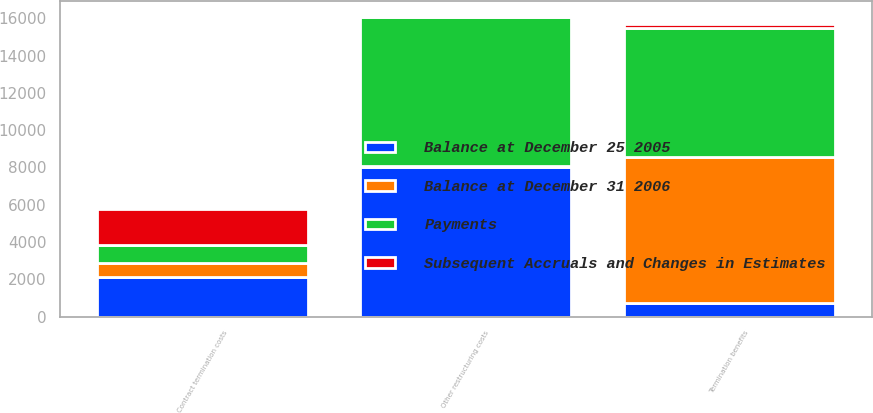<chart> <loc_0><loc_0><loc_500><loc_500><stacked_bar_chart><ecel><fcel>Termination benefits<fcel>Contract termination costs<fcel>Other restructuring costs<nl><fcel>Balance at December 31 2006<fcel>7848<fcel>775<fcel>31<nl><fcel>Balance at December 25 2005<fcel>706<fcel>2122<fcel>8039<nl><fcel>Payments<fcel>6938<fcel>945<fcel>7971<nl><fcel>Subsequent Accruals and Changes in Estimates<fcel>204<fcel>1952<fcel>99<nl></chart> 